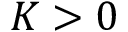<formula> <loc_0><loc_0><loc_500><loc_500>K > 0</formula> 